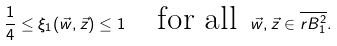Convert formula to latex. <formula><loc_0><loc_0><loc_500><loc_500>\frac { 1 } { 4 } \leq \xi _ { 1 } ( \vec { w } , \vec { z } ) \leq 1 \quad \text {for all } \, \vec { w } , \vec { z } \in \overline { r B _ { 1 } ^ { 2 } } .</formula> 